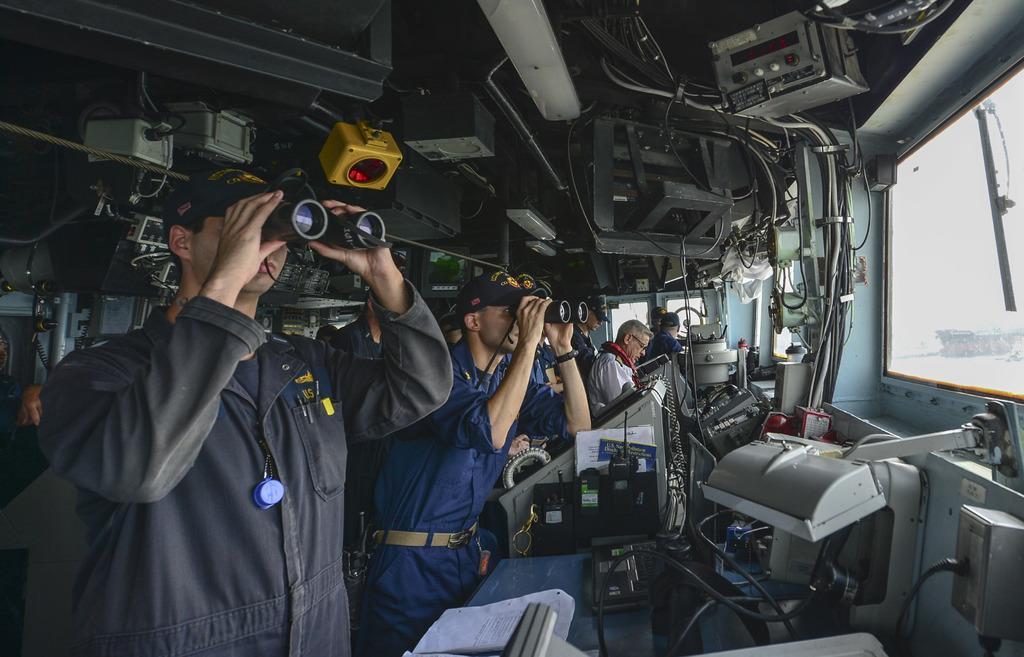Can you describe this image briefly? In this image we can see the people holding the binoculars. We can also see the other people standing. We can see the equipment, wires, papers and also the glass window. 